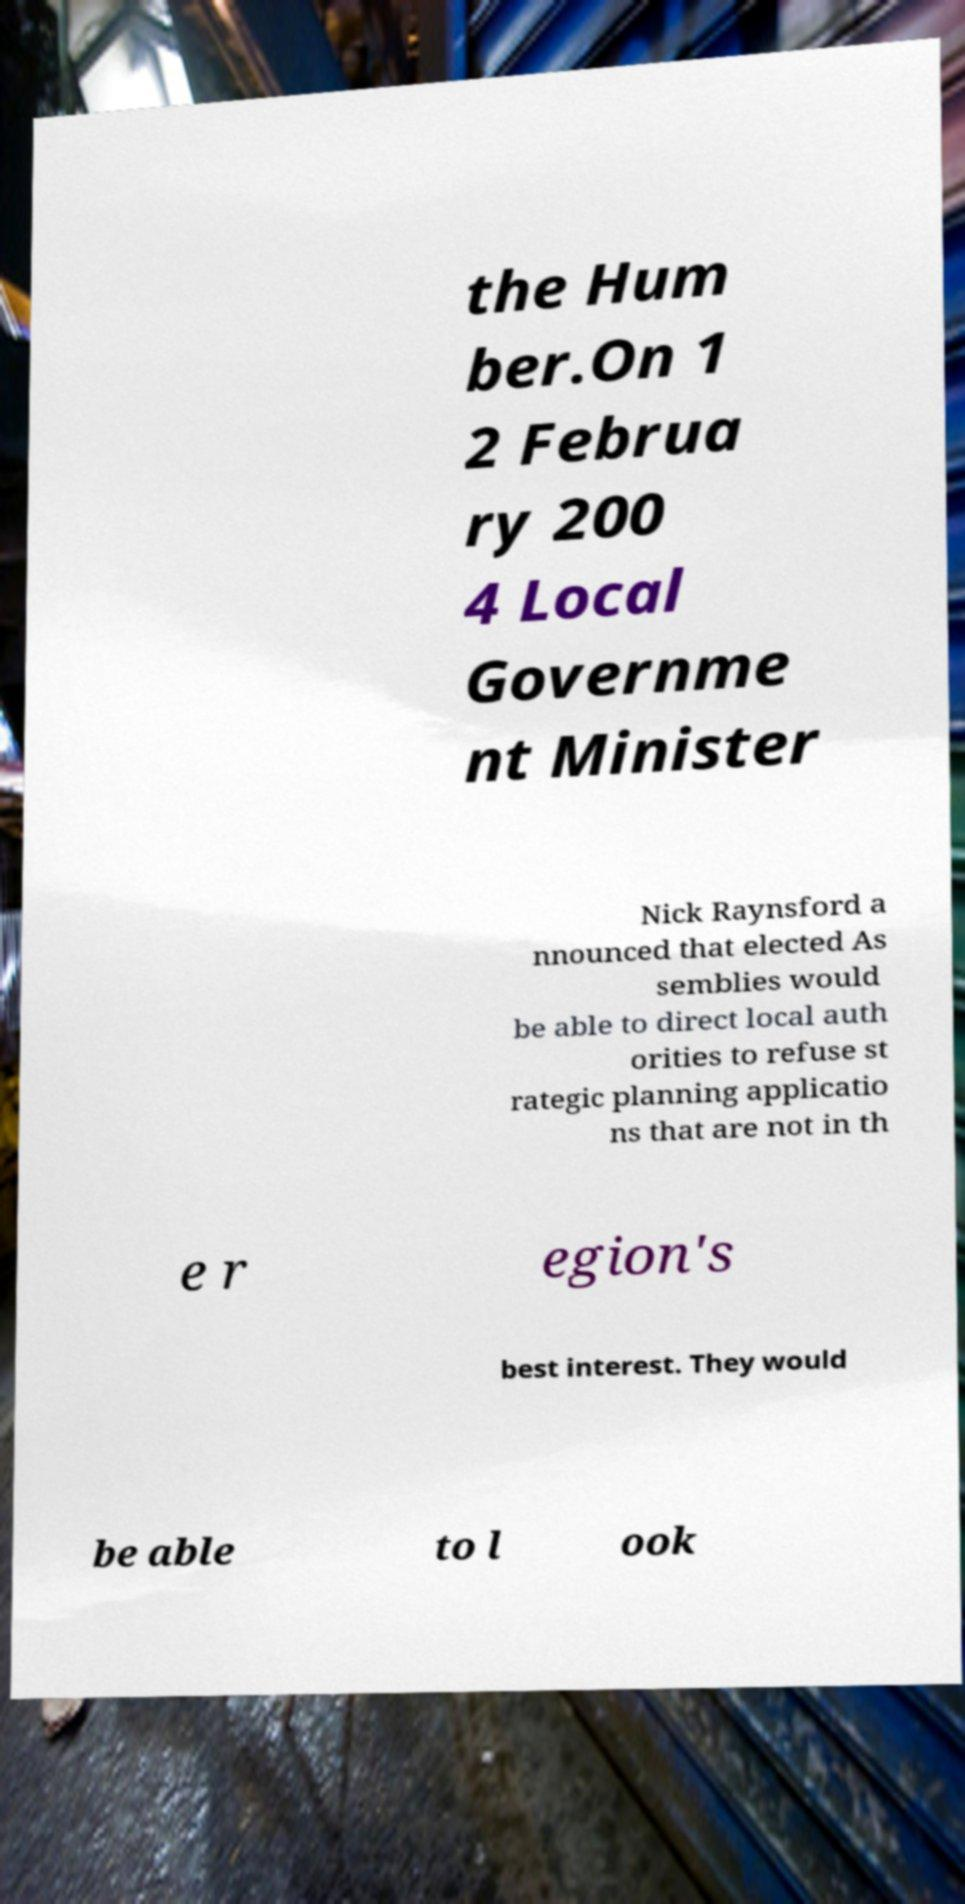Can you accurately transcribe the text from the provided image for me? the Hum ber.On 1 2 Februa ry 200 4 Local Governme nt Minister Nick Raynsford a nnounced that elected As semblies would be able to direct local auth orities to refuse st rategic planning applicatio ns that are not in th e r egion's best interest. They would be able to l ook 